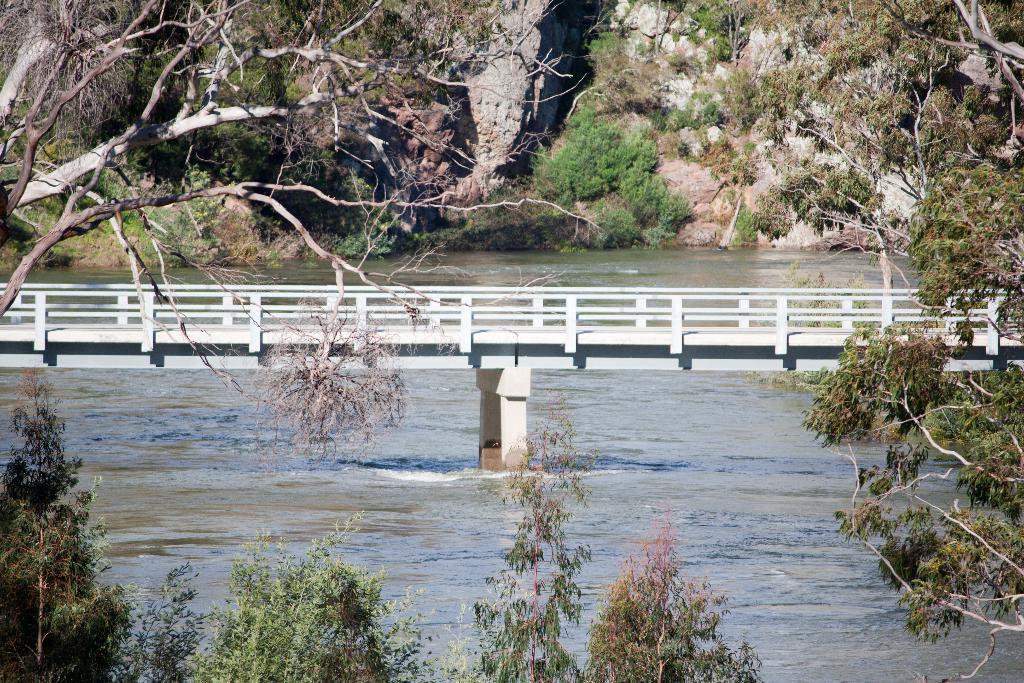Can you describe this image briefly? In this picture we can see a river under a white bridge surrounded by rocks, trees and bushes. 